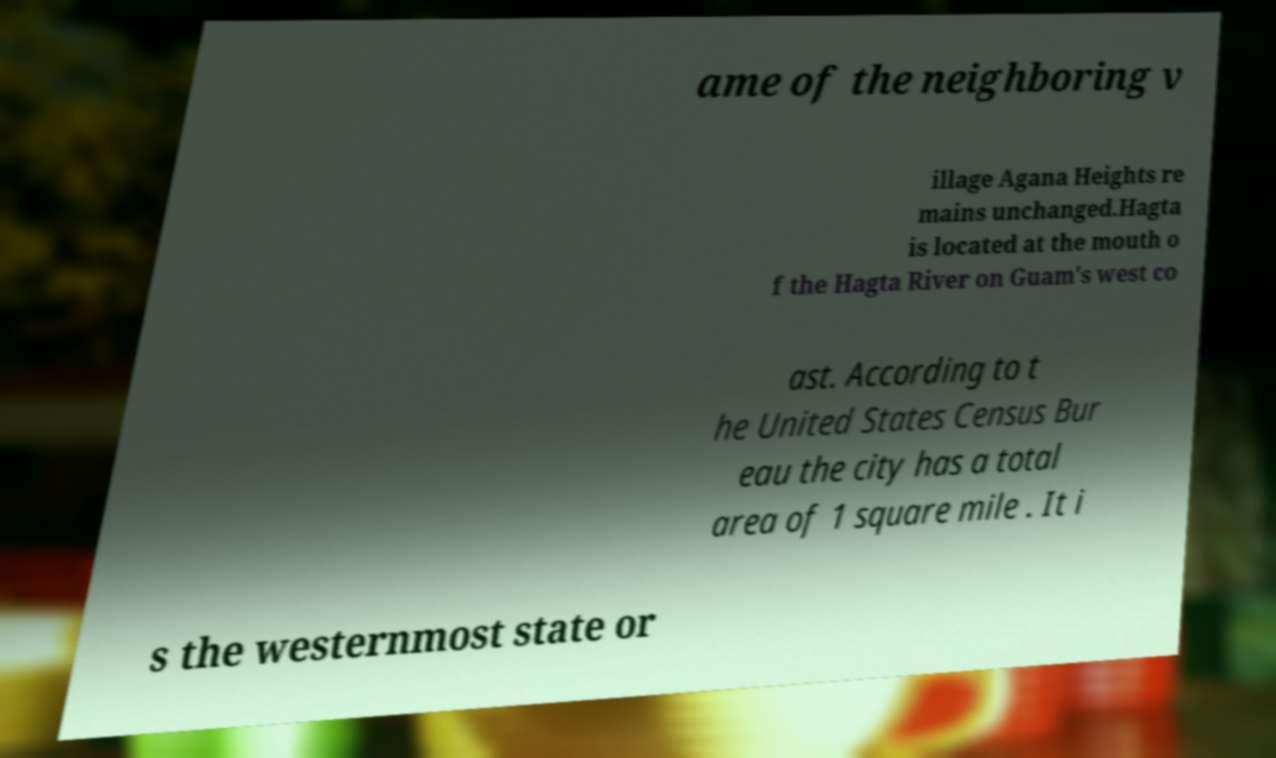Can you read and provide the text displayed in the image?This photo seems to have some interesting text. Can you extract and type it out for me? ame of the neighboring v illage Agana Heights re mains unchanged.Hagta is located at the mouth o f the Hagta River on Guam's west co ast. According to t he United States Census Bur eau the city has a total area of 1 square mile . It i s the westernmost state or 